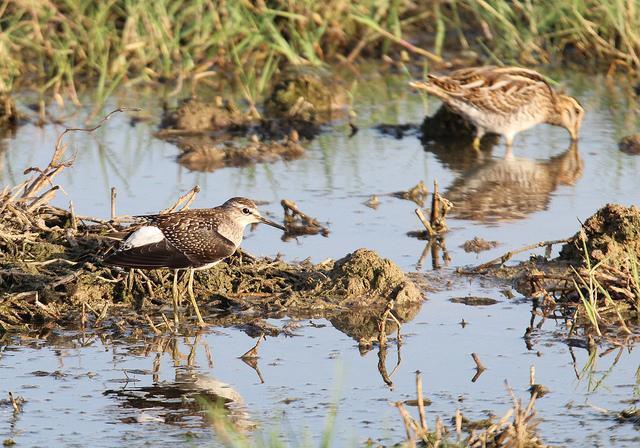How many birds are there?
Give a very brief answer. 2. How many birds can you see?
Give a very brief answer. 2. 